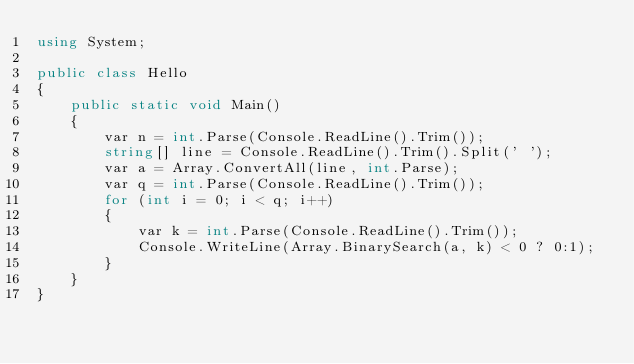Convert code to text. <code><loc_0><loc_0><loc_500><loc_500><_C#_>using System;

public class Hello
{
    public static void Main()
    {
        var n = int.Parse(Console.ReadLine().Trim());
        string[] line = Console.ReadLine().Trim().Split(' ');
        var a = Array.ConvertAll(line, int.Parse);
        var q = int.Parse(Console.ReadLine().Trim());
        for (int i = 0; i < q; i++)
        {
            var k = int.Parse(Console.ReadLine().Trim());
            Console.WriteLine(Array.BinarySearch(a, k) < 0 ? 0:1);
        }
    }
}
</code> 